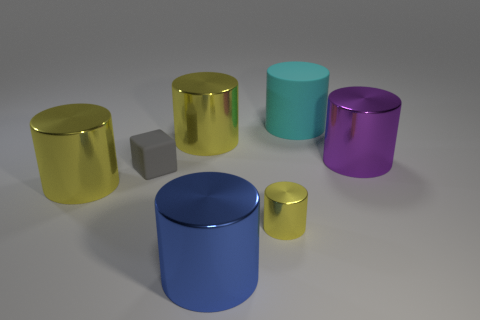What number of brown things are blocks or tiny cylinders?
Your response must be concise. 0. What is the color of the metal thing that is on the right side of the tiny object to the right of the large blue shiny thing?
Your answer should be compact. Purple. There is a big metallic object that is right of the small cylinder; what color is it?
Ensure brevity in your answer.  Purple. Do the shiny cylinder to the right of the cyan thing and the cyan rubber cylinder have the same size?
Offer a terse response. Yes. Are there any metallic cylinders of the same size as the rubber block?
Offer a terse response. Yes. There is a small object that is in front of the tiny gray rubber block; does it have the same color as the large cylinder left of the small block?
Offer a very short reply. Yes. Is there a big cylinder that has the same color as the small cylinder?
Provide a short and direct response. Yes. How many other things are there of the same shape as the tiny gray thing?
Provide a succinct answer. 0. What shape is the matte thing that is to the right of the tiny cylinder?
Make the answer very short. Cylinder. Is the shape of the cyan rubber thing the same as the small object to the left of the tiny metal thing?
Ensure brevity in your answer.  No. 